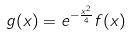<formula> <loc_0><loc_0><loc_500><loc_500>g ( x ) = e ^ { - \frac { x ^ { 2 } } { 4 } } f ( x )</formula> 